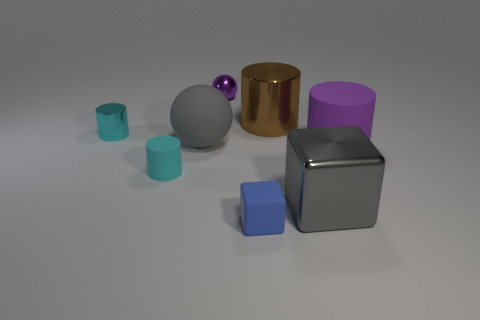What material is the large cylinder that is the same color as the small metal sphere?
Offer a very short reply. Rubber. Is the material of the purple thing that is left of the blue cube the same as the gray ball?
Make the answer very short. No. There is a object to the left of the cylinder that is in front of the large purple matte cylinder; is there a large purple cylinder on the right side of it?
Offer a very short reply. Yes. What number of cylinders are either small cyan matte things or small purple things?
Provide a short and direct response. 1. There is a big object to the left of the small purple sphere; what is its material?
Your answer should be compact. Rubber. What size is the cube that is the same color as the rubber ball?
Keep it short and to the point. Large. There is a rubber object that is right of the gray metal thing; is it the same color as the metal cylinder that is on the left side of the brown shiny thing?
Provide a succinct answer. No. What number of things are either rubber spheres or tiny brown shiny objects?
Keep it short and to the point. 1. How many other objects are there of the same shape as the tiny purple object?
Provide a succinct answer. 1. Do the sphere in front of the tiny cyan shiny thing and the cube to the left of the gray cube have the same material?
Offer a very short reply. Yes. 